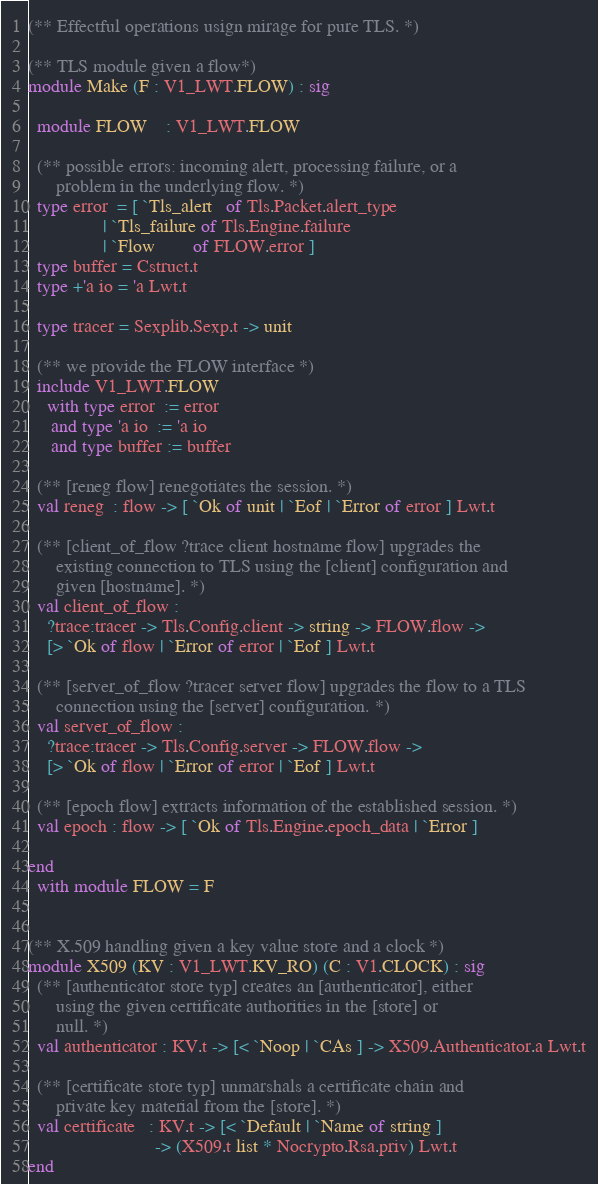<code> <loc_0><loc_0><loc_500><loc_500><_OCaml_>(** Effectful operations usign mirage for pure TLS. *)

(** TLS module given a flow*)
module Make (F : V1_LWT.FLOW) : sig

  module FLOW    : V1_LWT.FLOW

  (** possible errors: incoming alert, processing failure, or a
      problem in the underlying flow. *)
  type error  = [ `Tls_alert   of Tls.Packet.alert_type
                | `Tls_failure of Tls.Engine.failure
                | `Flow        of FLOW.error ]
  type buffer = Cstruct.t
  type +'a io = 'a Lwt.t

  type tracer = Sexplib.Sexp.t -> unit

  (** we provide the FLOW interface *)
  include V1_LWT.FLOW
    with type error  := error
     and type 'a io  := 'a io
     and type buffer := buffer

  (** [reneg flow] renegotiates the session. *)
  val reneg  : flow -> [ `Ok of unit | `Eof | `Error of error ] Lwt.t

  (** [client_of_flow ?trace client hostname flow] upgrades the
      existing connection to TLS using the [client] configuration and
      given [hostname]. *)
  val client_of_flow :
    ?trace:tracer -> Tls.Config.client -> string -> FLOW.flow ->
    [> `Ok of flow | `Error of error | `Eof ] Lwt.t

  (** [server_of_flow ?tracer server flow] upgrades the flow to a TLS
      connection using the [server] configuration. *)
  val server_of_flow :
    ?trace:tracer -> Tls.Config.server -> FLOW.flow ->
    [> `Ok of flow | `Error of error | `Eof ] Lwt.t

  (** [epoch flow] extracts information of the established session. *)
  val epoch : flow -> [ `Ok of Tls.Engine.epoch_data | `Error ]

end
  with module FLOW = F


(** X.509 handling given a key value store and a clock *)
module X509 (KV : V1_LWT.KV_RO) (C : V1.CLOCK) : sig
  (** [authenticator store typ] creates an [authenticator], either
      using the given certificate authorities in the [store] or
      null. *)
  val authenticator : KV.t -> [< `Noop | `CAs ] -> X509.Authenticator.a Lwt.t

  (** [certificate store typ] unmarshals a certificate chain and
      private key material from the [store]. *)
  val certificate   : KV.t -> [< `Default | `Name of string ]
                           -> (X509.t list * Nocrypto.Rsa.priv) Lwt.t
end
</code> 